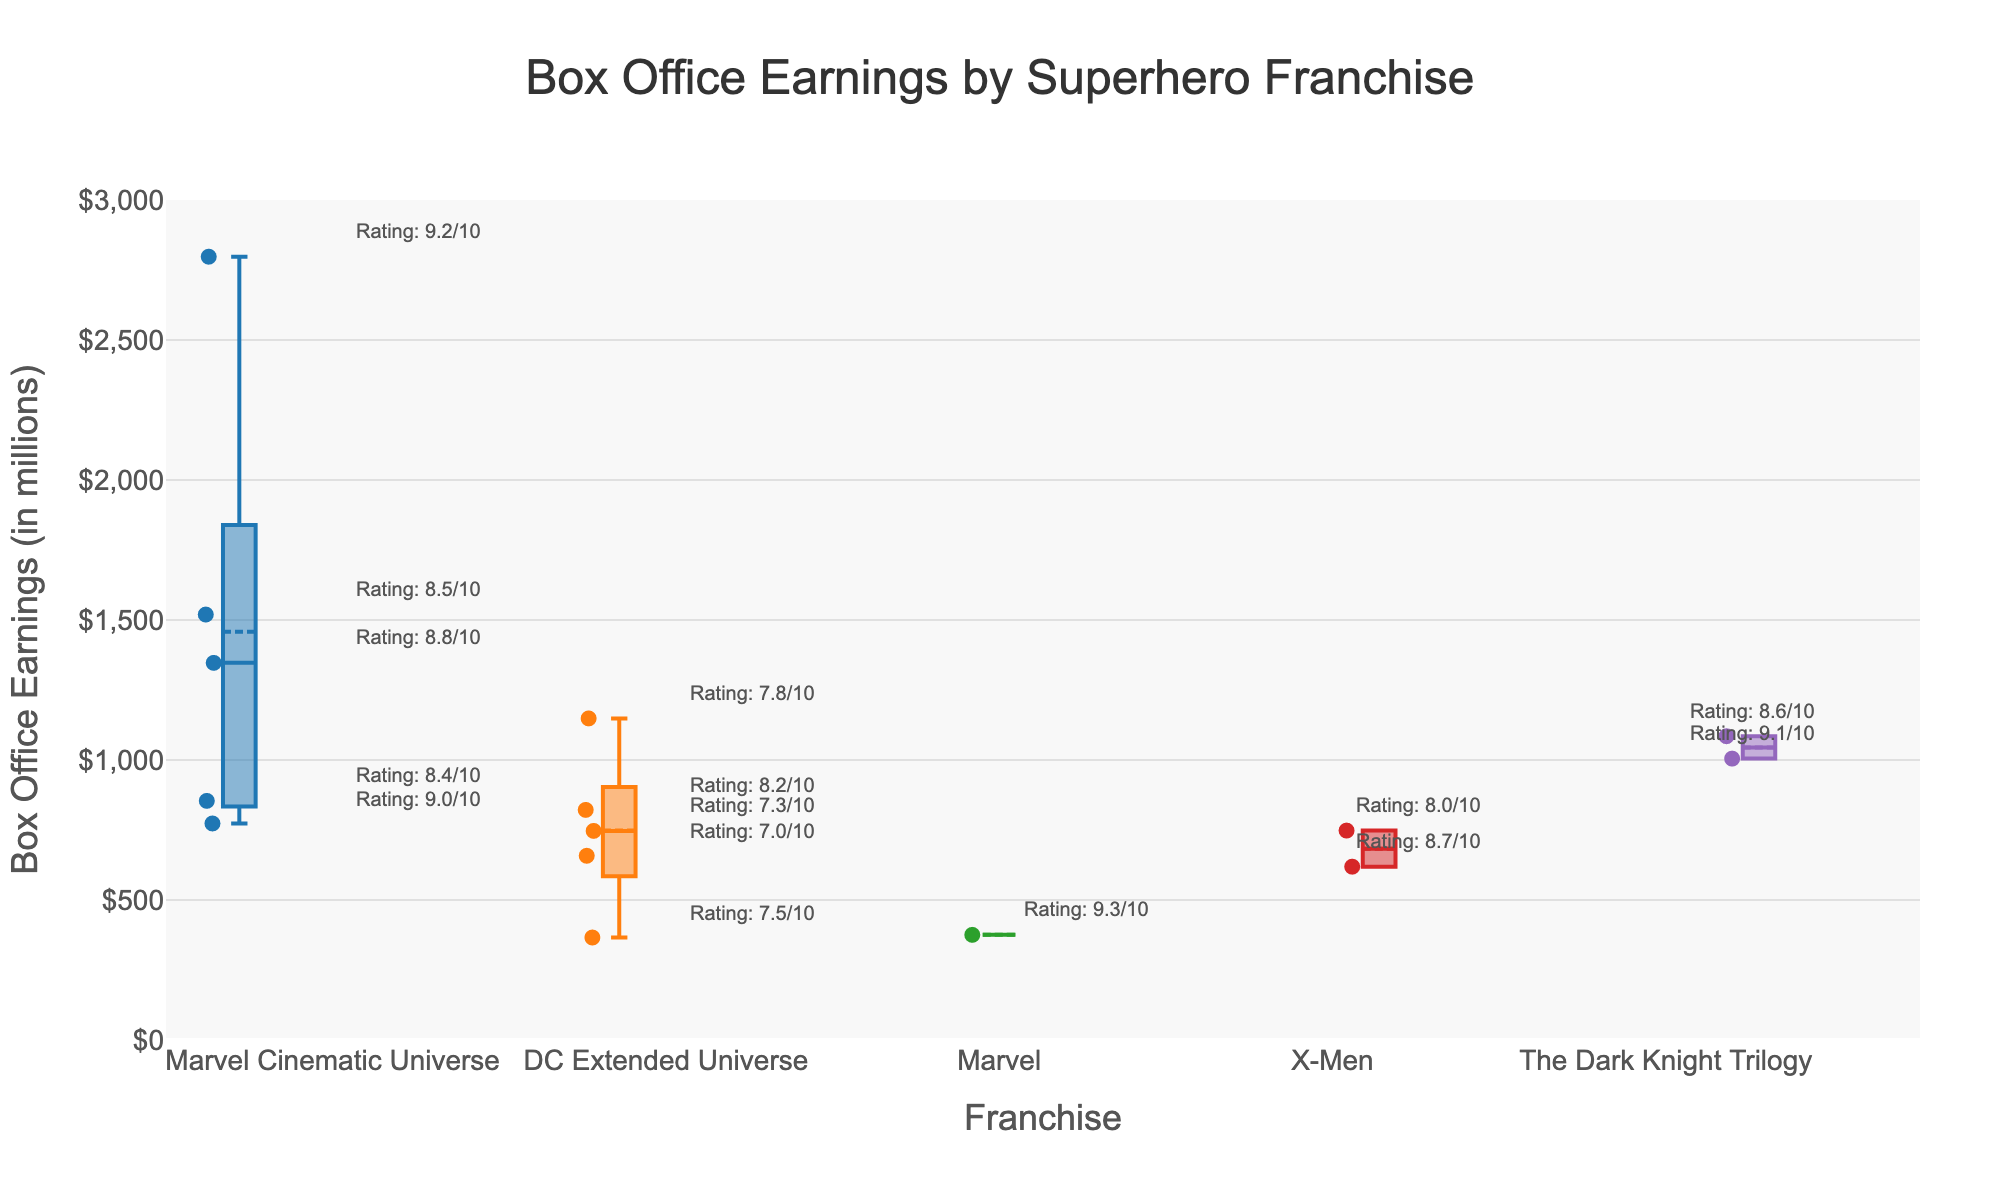What's the title of the box plot? The title is positioned at the top center of the figure, specifying the content represented in the plot.
Answer: Box Office Earnings by Superhero Franchise How many franchises are represented in the box plot? The number of box plots corresponds to the number of unique franchise names in the x-axis labels.
Answer: Five Which franchise has the highest median box office earnings? To find the highest median, locate the middle line in each box plot and compare their positions relative to the y-axis.
Answer: Marvel Cinematic Universe What is the range of box office earnings for films in the DC Extended Universe franchise? The range is determined by the difference between the highest and lowest points of the "whiskers" of the box plot for the DC Extended Universe.
Answer: Approximately 366 to 1148.5 million Which film has the highest box office earnings? Box office earnings are represented by individual points within the box plots, the highest of which touches or goes beyond the top whisker.
Answer: Avengers: Endgame How does the box office earnings of The Dark Knight compare to The Dark Knight Rises? Compare the positions of the individual points or annotations of both films within the respective box plots for The Dark Knight Trilogy.
Answer: The Dark Knight Rises has slightly higher box office earnings What is the range of soundtrack ratings for Marvel Cinematic Universe films? Analyze the text annotations within the Marvel Cinematic Universe box plot to find the minimum and maximum soundtrack ratings mentioned.
Answer: 8.4 to 9.2 Which Marvel film has the highest soundtrack rating, and what is its box office earnings? Look for the highest soundtrack rating annotation within the Marvel Cinematic Universe box plot and note its associated earnings.
Answer: Avengers: Endgame with 2797.5 million Is the box office earnings interquartile range (IQR) larger for The Dark Knight Trilogy or the X-Men franchise? Compare the lengths of the boxes, which represent the IQR, in the box plots for both franchises.
Answer: The Dark Knight Trilogy What is the median soundtrack rating of the films in the data? Since the soundtrack rating annotations are textual and located near the points, sort these ratings and find the middle value.
Answer: 8.4 